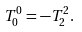Convert formula to latex. <formula><loc_0><loc_0><loc_500><loc_500>T _ { 0 } ^ { 0 } = - T _ { 2 } ^ { 2 } .</formula> 